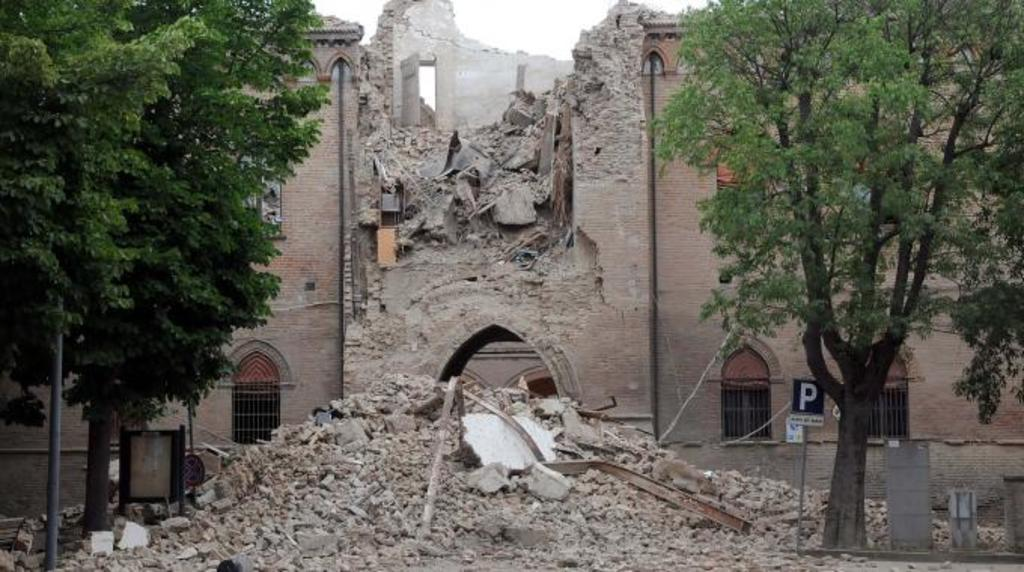What is the main subject of the image? The main subject of the image is a collapsed building. What can be seen in front of the building? There are trees and an iron pole in front of the building. Is there any signage visible in the image? Yes, there is a sign board in front of the building. Can you see a frog jumping in a circle in the image? There is no frog or circle present in the image. How many stitches are visible on the collapsed building in the image? The image does not show any stitches on the building, as it is a photograph and not a fabric or textile. 